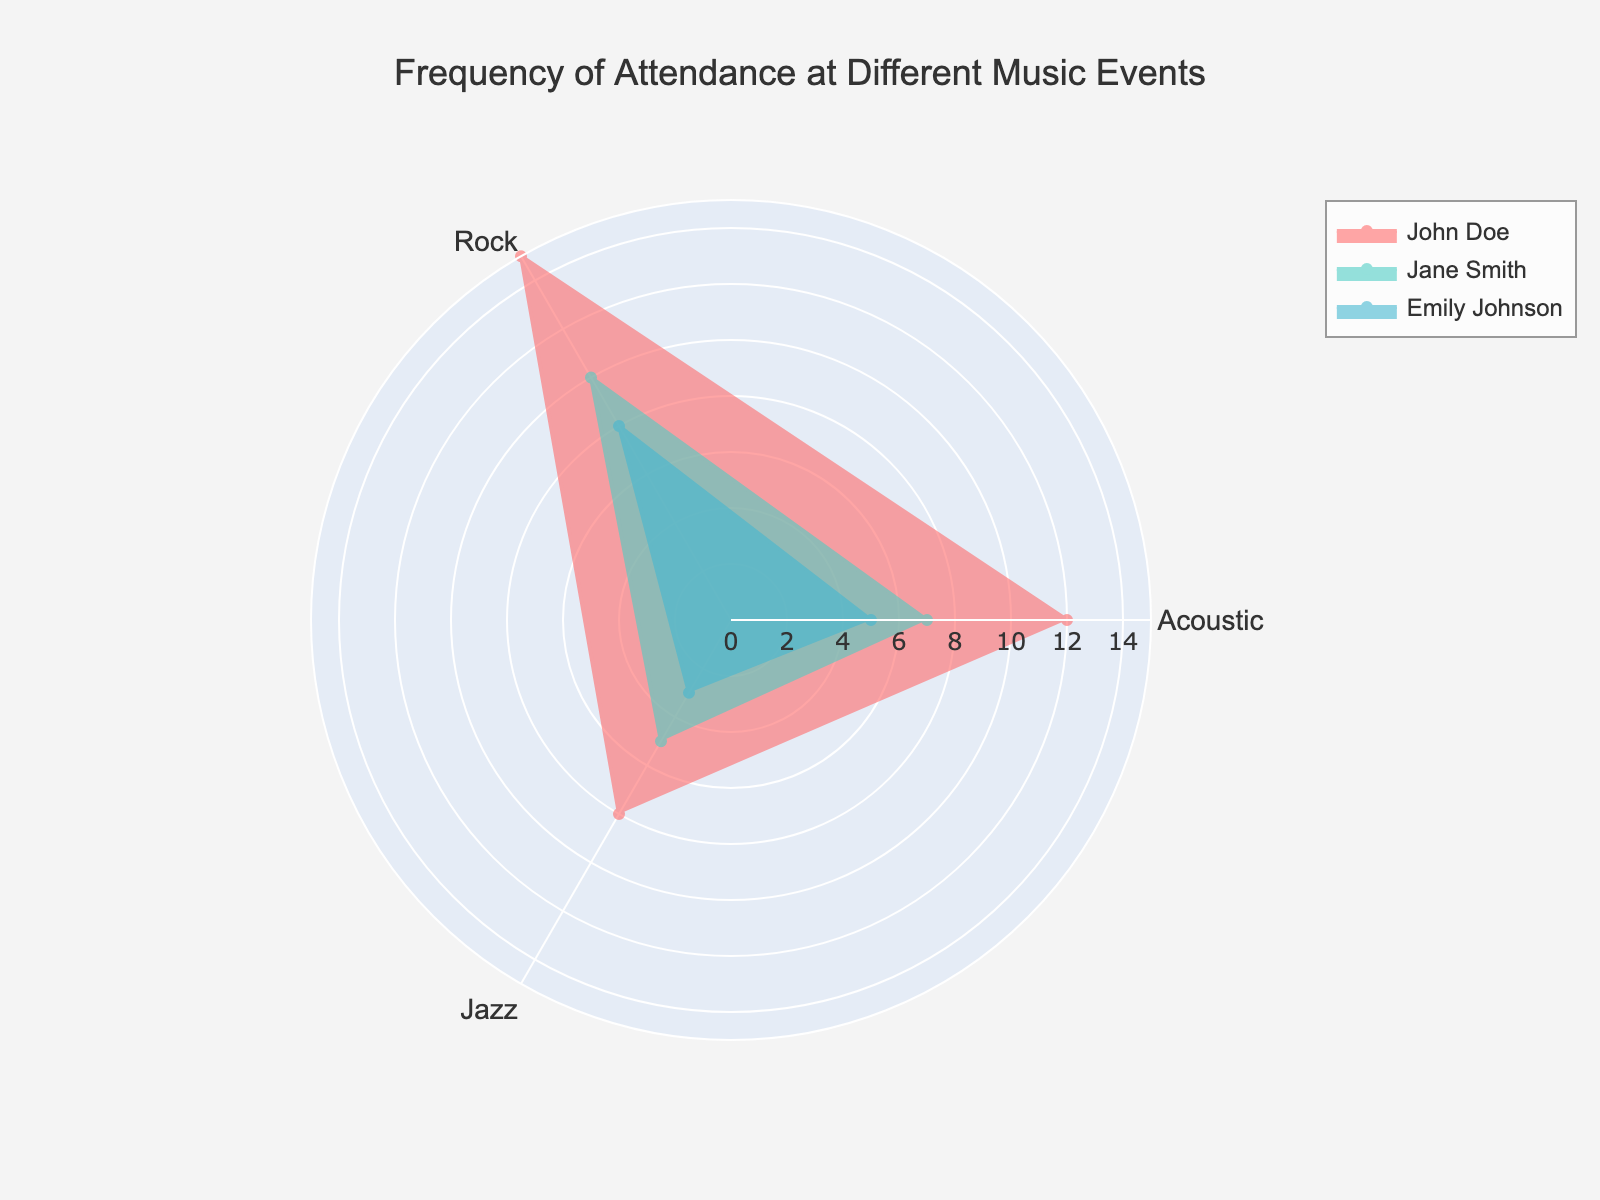What's the title of the radar chart? The title is located at the top center of the radar chart.
Answer: Frequency of Attendance at Different Music Events What are the three event types displayed in the radar chart? The event types are shown along the axes of the radar chart.
Answer: Acoustic, Rock, Jazz Which attendee has the highest overall frequency of attendance? By comparing the filled area for each attendee, we see that Jane Smith's shape covers more area overall.
Answer: Jane Smith What is the difference in frequency of attendance at Acoustic events between John Doe and Emily Johnson? From the Acoustic axis, John Doe's value is 12 and Emily Johnson's value is 8. The difference is 12 - 8.
Answer: 4 On average, how many Jazz events do Jane Smith and John Doe attend? Jane Smith attends 8 Jazz events, and John Doe attends 5 Jazz events. The average is (8 + 5) / 2.
Answer: 6.5 Which music event does Emily Johnson attend the least? Emily Johnson's radar chart values at each axis are checked, and the smallest value is 3, at Jazz events.
Answer: Jazz How does Jane Smith's attendance at Rock events compare to John Doe's? Check the Rock axis values; Jane Smith attends 10 and John Doe attends 7.
Answer: Jane Smith attends 3 more Rock events than John Doe Who has the highest frequency of attendance at Acoustic events? By comparing the Acoustic axis values, Jane Smith has the highest at 15.
Answer: Jane Smith What's the total frequency of attendance for Rock events across all attendees? Sum the Rock event values for all attendees: 7 (John Doe) + 10 (Jane Smith) + 5 (Emily Johnson) = 22
Answer: 22 Which attendee's attendance is most balanced (least variance) across the three event types? Compare the variance in the radar chart shapes. Emily Johnson shows the smallest range of values (8, 5, 3 = variance of 5), making her attendance the most balanced.
Answer: Emily Johnson 